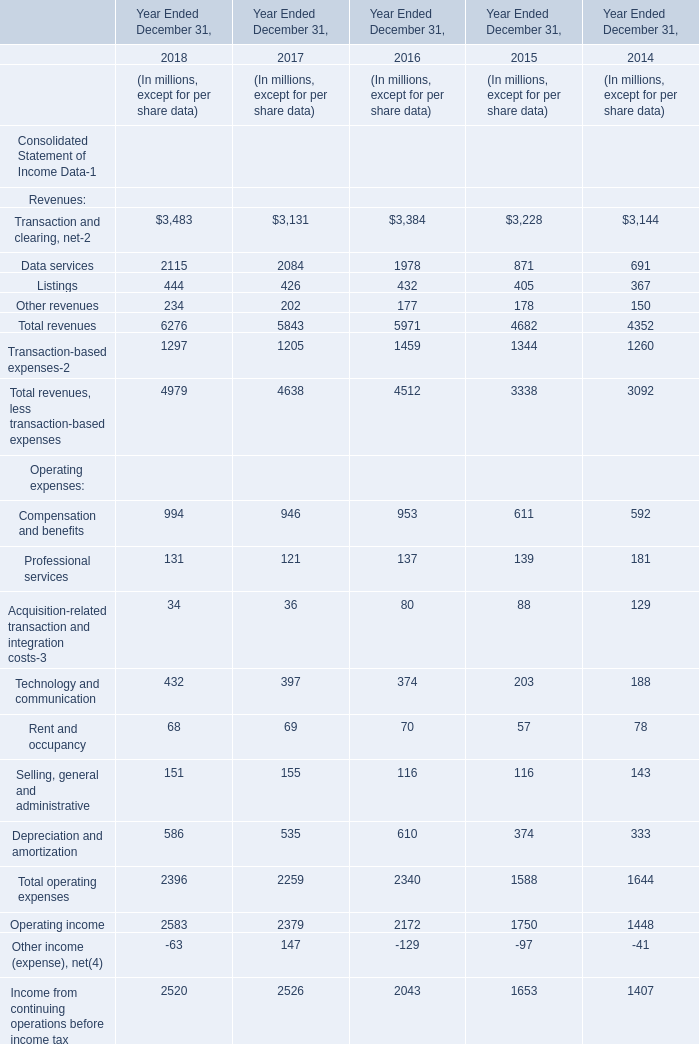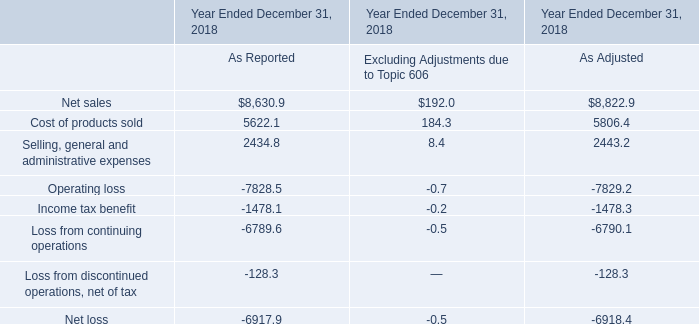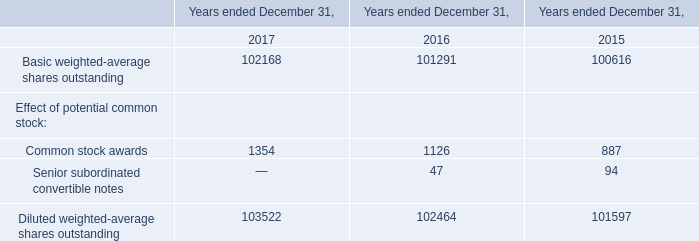What is the difference between 2018 and 2017 's highest Data services? (in million) 
Computations: (2115 - 2084)
Answer: 31.0. 